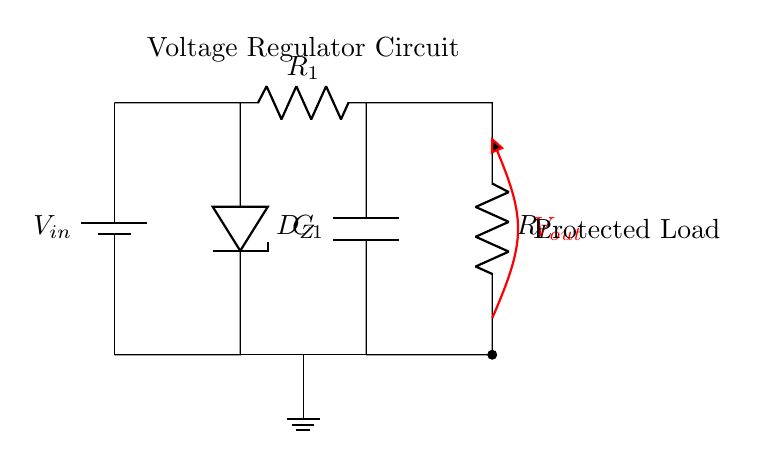What components are in the circuit? The circuit includes a battery, Zener diode, resistor, capacitor, and load resistor. Each of these components is clearly labeled in the diagram, indicating their roles in the voltage regulation system.
Answer: battery, Zener diode, resistor, capacitor, load What does the Zener diode do in this circuit? The Zener diode serves to regulate the output voltage, maintaining a steady voltage level despite fluctuations in the input voltage. It ensures that sensitive devices receive a consistent voltage during brownouts.
Answer: regulate output voltage What is the purpose of the capacitor? The capacitor acts as a filter, smoothing out variations in the output voltage and providing temporary energy storage to maintain voltage during short dips. This ensures the load receives a stable current.
Answer: filter and energy storage How does the load affect this circuit during a brownout? During a brownout, the load relies on the voltage regulator to maintain consistent voltage, preventing potential damage to sensitive electronic devices. The regulator responds to voltage drops to keep output stable.
Answer: maintains consistent voltage What role does the input voltage play in the circuit? The input voltage determines how well the voltage regulator can function, as it must be sufficiently above the desired output voltage to ensure that the Zener diode can properly regulate the voltage at the output.
Answer: determines regulator functionality What is the output voltage in this circuit? The output voltage is marked as Vout, which is the voltage delivered to the protected load, regulated by the Zener diode and capacitor in response to the input conditions.
Answer: Vout 